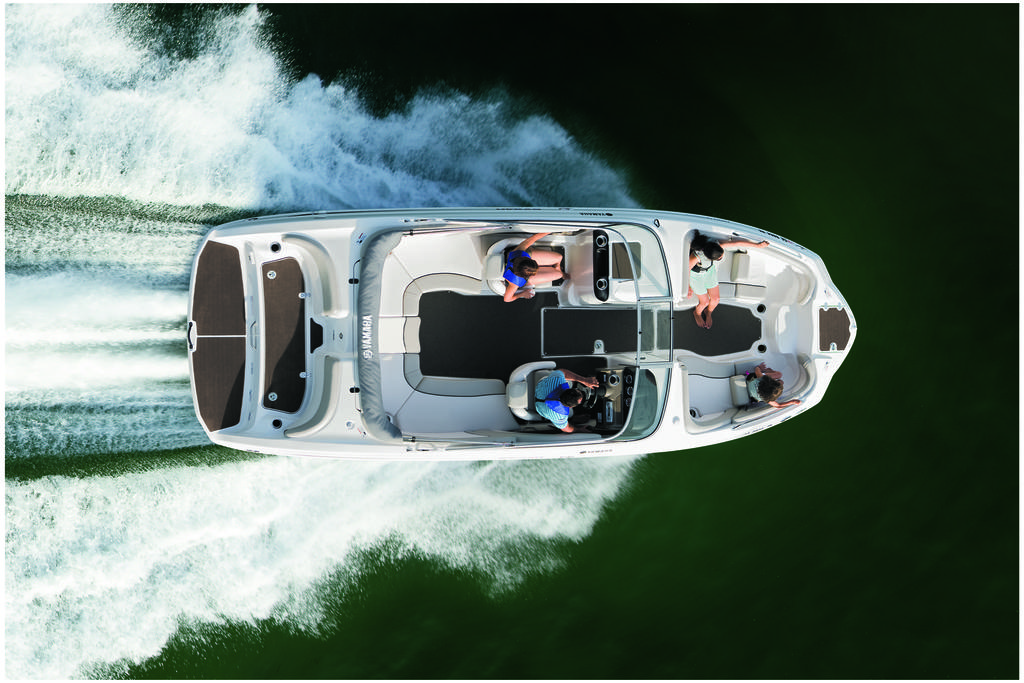What is the main subject of the image? The main subject of the image is a boat. Where is the boat located in the image? The boat is on the water. How many people are in the boat? There are four persons sitting in the boat. What type of sweater is the beef wearing in the image? There is no beef or sweater present in the image, as it features a boat on the water with four persons sitting in it. 